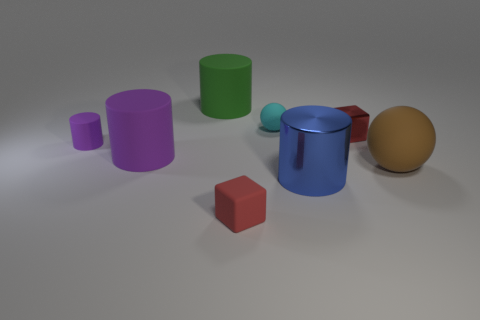Subtract all purple cylinders. How many were subtracted if there are1purple cylinders left? 1 Add 1 red objects. How many objects exist? 9 Subtract all small purple cylinders. How many cylinders are left? 3 Subtract all cyan balls. How many balls are left? 1 Subtract 2 cylinders. How many cylinders are left? 2 Add 8 rubber cubes. How many rubber cubes are left? 9 Add 3 cylinders. How many cylinders exist? 7 Subtract 2 red blocks. How many objects are left? 6 Subtract all spheres. How many objects are left? 6 Subtract all yellow cylinders. Subtract all green balls. How many cylinders are left? 4 